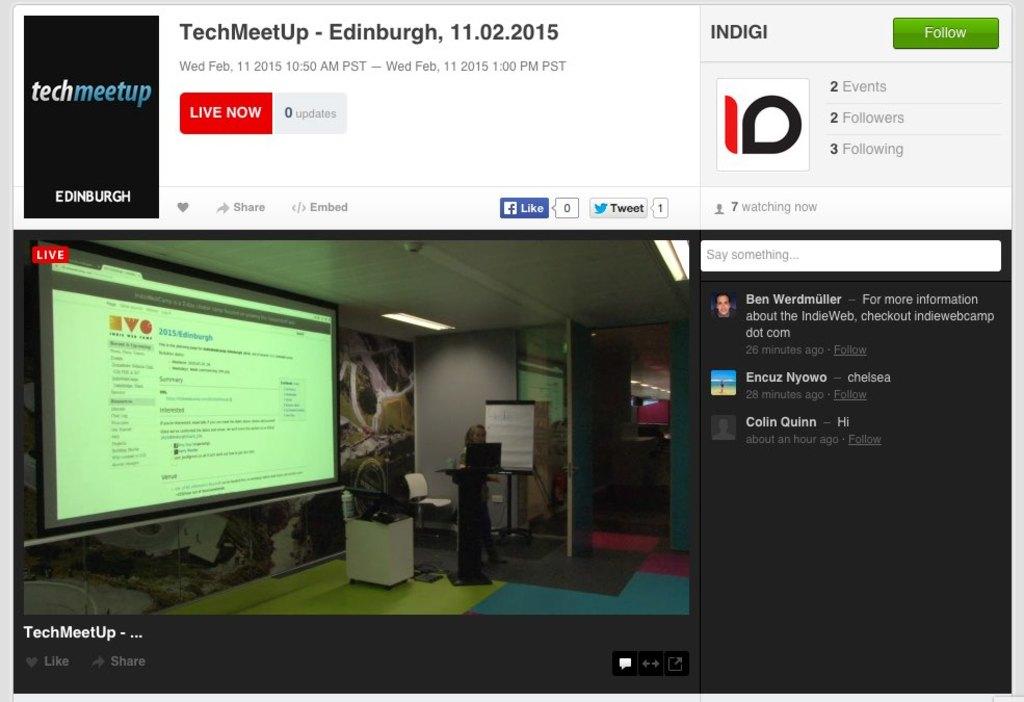How many followers does this page have?
Your answer should be compact. 2. What year did the stream take place in?
Keep it short and to the point. 2015. 